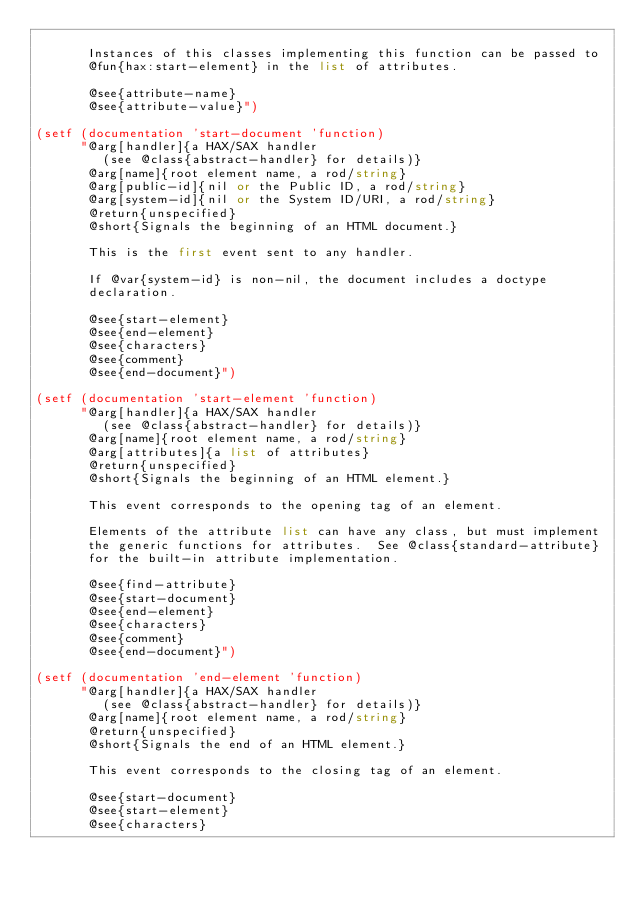Convert code to text. <code><loc_0><loc_0><loc_500><loc_500><_Lisp_>
       Instances of this classes implementing this function can be passed to
       @fun{hax:start-element} in the list of attributes.

       @see{attribute-name}
       @see{attribute-value}")

(setf (documentation 'start-document 'function)
      "@arg[handler]{a HAX/SAX handler
         (see @class{abstract-handler} for details)}
       @arg[name]{root element name, a rod/string}
       @arg[public-id]{nil or the Public ID, a rod/string}
       @arg[system-id]{nil or the System ID/URI, a rod/string}
       @return{unspecified}
       @short{Signals the beginning of an HTML document.}

       This is the first event sent to any handler.

       If @var{system-id} is non-nil, the document includes a doctype
       declaration.

       @see{start-element}
       @see{end-element}
       @see{characters}
       @see{comment}
       @see{end-document}")

(setf (documentation 'start-element 'function)
      "@arg[handler]{a HAX/SAX handler
         (see @class{abstract-handler} for details)}
       @arg[name]{root element name, a rod/string}
       @arg[attributes]{a list of attributes}
       @return{unspecified}
       @short{Signals the beginning of an HTML element.}

       This event corresponds to the opening tag of an element.

       Elements of the attribute list can have any class, but must implement
       the generic functions for attributes.  See @class{standard-attribute}
       for the built-in attribute implementation.

       @see{find-attribute}
       @see{start-document}
       @see{end-element}
       @see{characters}
       @see{comment}
       @see{end-document}")

(setf (documentation 'end-element 'function)
      "@arg[handler]{a HAX/SAX handler
         (see @class{abstract-handler} for details)}
       @arg[name]{root element name, a rod/string}
       @return{unspecified}
       @short{Signals the end of an HTML element.}

       This event corresponds to the closing tag of an element.

       @see{start-document}
       @see{start-element}
       @see{characters}</code> 